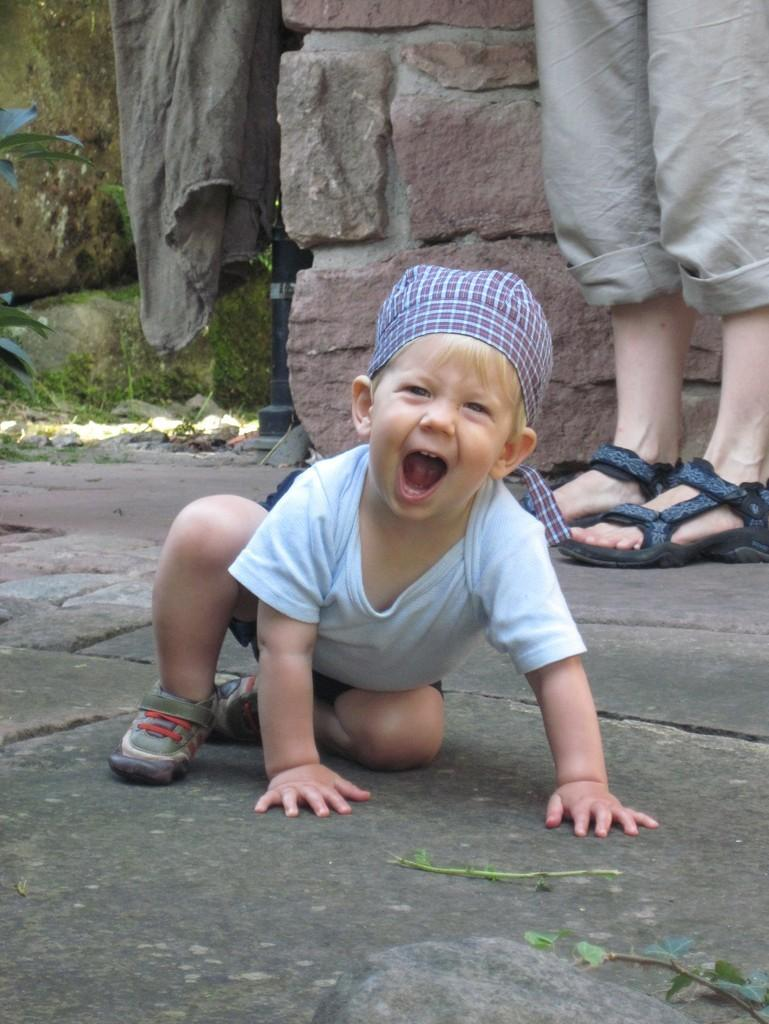Who is in the image? There is a boy in the image. What is the boy doing in the image? The boy is on a surface in the image. What can be seen on the boy's feet? There are legs with footwear visible in the image. What is visible in the background of the image? There is a wall, leaves, grass, and cloth visible in the background of the image. What color is the silk card in the image? There is no silk card present in the image. 